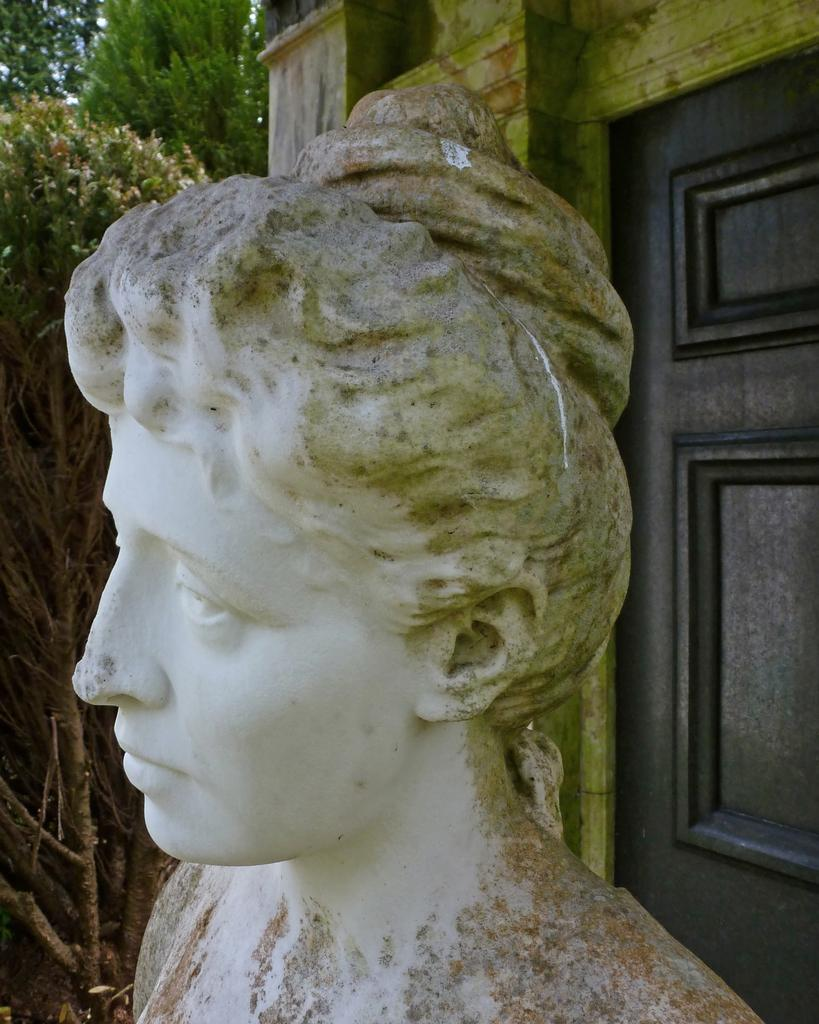What type of structure is present in the picture? There is a house in the picture. Can you identify any specific features of the house? There is a door in the picture. What other objects or elements can be seen in the picture? There are trees and a statue of a woman in the picture. What color is the crayon being used by the statue in the picture? There is no crayon present in the picture, and the statue is not depicted as using one. 